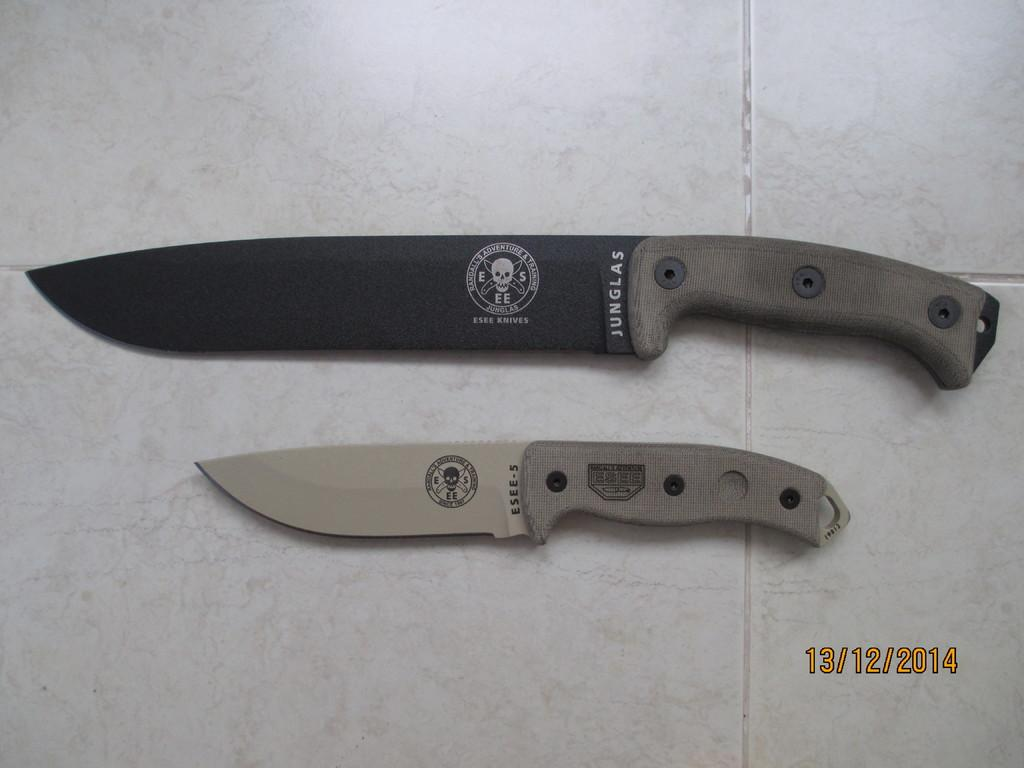<image>
Provide a brief description of the given image. A Junglas knife sits on a table along with a smaller knife. 